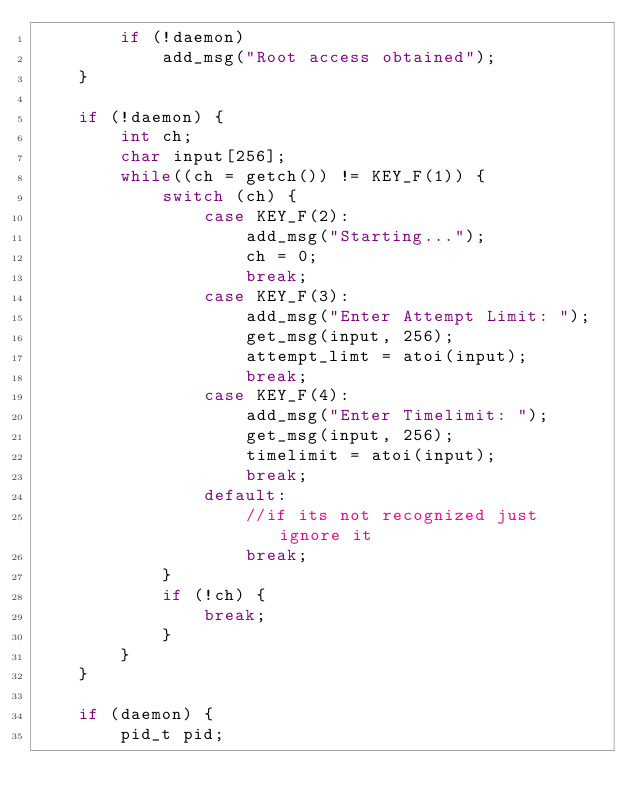<code> <loc_0><loc_0><loc_500><loc_500><_C_>        if (!daemon)
            add_msg("Root access obtained");
    }

    if (!daemon) {
        int ch;
        char input[256];
        while((ch = getch()) != KEY_F(1)) {
            switch (ch) {
                case KEY_F(2):
                    add_msg("Starting...");
                    ch = 0;
                    break;
                case KEY_F(3):
                    add_msg("Enter Attempt Limit: ");
                    get_msg(input, 256);
                    attempt_limt = atoi(input);
                    break;
                case KEY_F(4):
                    add_msg("Enter Timelimit: ");
                    get_msg(input, 256);
                    timelimit = atoi(input);
                    break;
                default:
                    //if its not recognized just ignore it
                    break;
            }
            if (!ch) {
                break;
            }
        }
    }

    if (daemon) {
        pid_t pid;</code> 